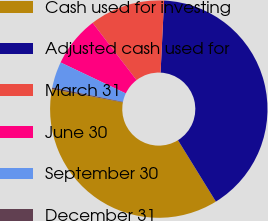Convert chart to OTSL. <chart><loc_0><loc_0><loc_500><loc_500><pie_chart><fcel>Cash used for investing<fcel>Adjusted cash used for<fcel>March 31<fcel>June 30<fcel>September 30<fcel>December 31<nl><fcel>36.76%<fcel>40.42%<fcel>11.19%<fcel>7.53%<fcel>3.88%<fcel>0.22%<nl></chart> 